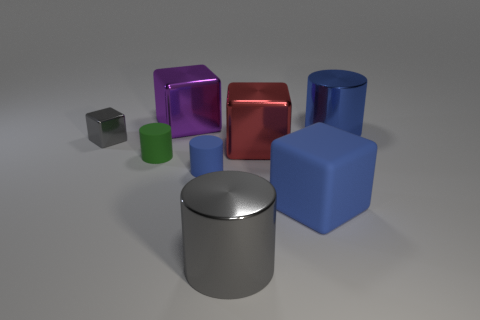What material is the large cube that is to the right of the big purple metallic block and behind the blue matte block?
Offer a terse response. Metal. The large blue object that is made of the same material as the gray cylinder is what shape?
Offer a terse response. Cylinder. Is there any other thing that is the same shape as the small gray thing?
Keep it short and to the point. Yes. Do the cylinder that is behind the small shiny object and the tiny gray block have the same material?
Give a very brief answer. Yes. There is a gray object that is behind the small green rubber cylinder; what is its material?
Provide a short and direct response. Metal. There is a shiny cylinder that is to the right of the big blue object on the left side of the blue shiny thing; what size is it?
Your answer should be very brief. Large. What number of blue rubber things are the same size as the green rubber thing?
Ensure brevity in your answer.  1. There is a large metallic cylinder that is in front of the small gray metal object; is it the same color as the shiny block on the left side of the large purple metallic object?
Make the answer very short. Yes. Are there any purple metallic cubes behind the small green cylinder?
Make the answer very short. Yes. The thing that is left of the purple shiny cube and in front of the tiny gray block is what color?
Provide a short and direct response. Green. 